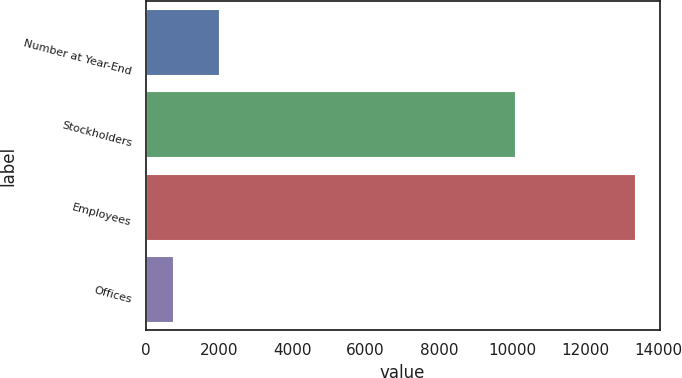Convert chart. <chart><loc_0><loc_0><loc_500><loc_500><bar_chart><fcel>Number at Year-End<fcel>Stockholders<fcel>Employees<fcel>Offices<nl><fcel>2006<fcel>10084<fcel>13352<fcel>736<nl></chart> 